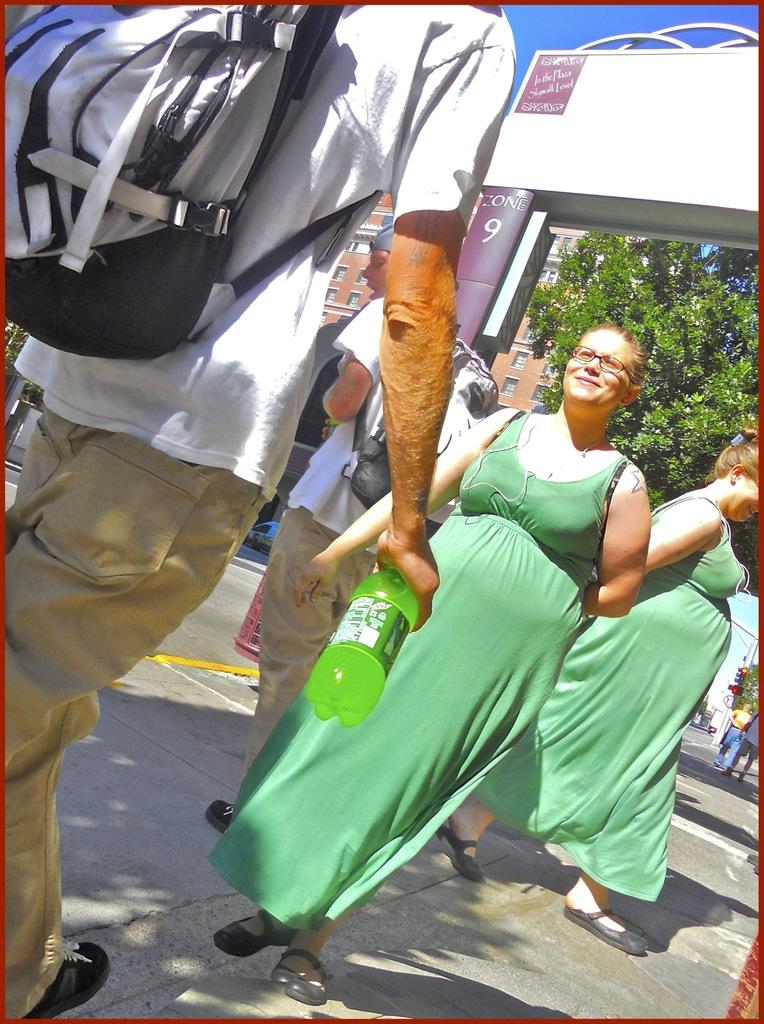What are the people in the image doing? There are men and women walking in the image. What object can be seen in the image that might be used for carrying items? There is a bag in the image. What object in the image might be used for holding a liquid? There is a bottle in the image. What type of plant is visible in the image? There is a tree in the image. What type of structure is visible in the image? There is a building with windows in the image. What part of the natural environment is visible in the image? The sky is visible in the image. How many ducks are flying in the image? There are no ducks visible in the image. What type of mass is present in the image? There is no specific mass mentioned or visible in the image. 